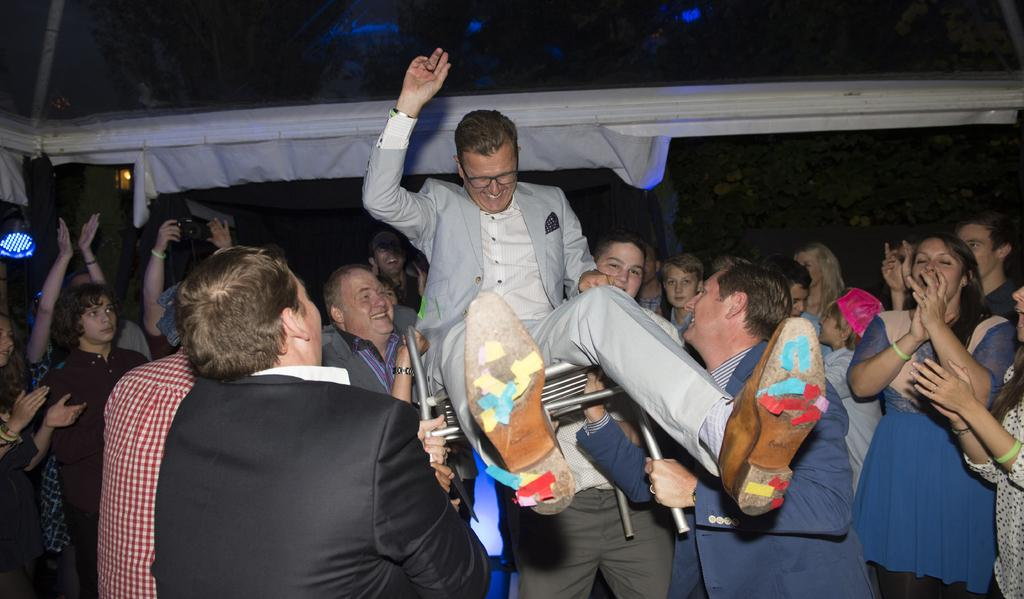What are the people in the image doing? The people in the image are standing in the center and holding a person in a chair. What can be seen in the background of the image? There are trees visible in the background of the image. What type of line is being used to match the person in the chair? There is no line or matching activity present in the image; it features people holding a person in a chair with trees in the background. 